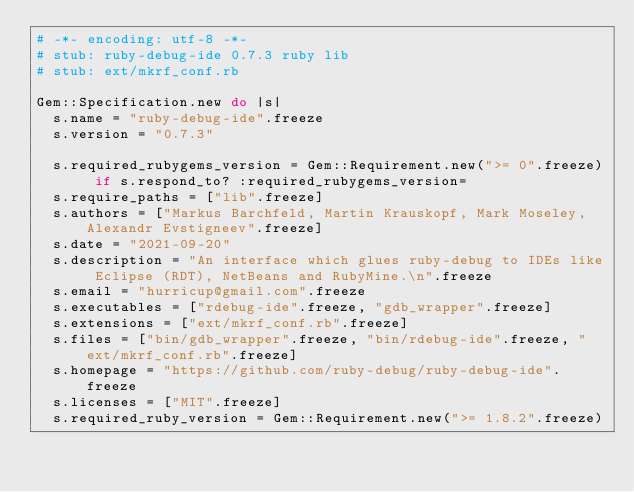<code> <loc_0><loc_0><loc_500><loc_500><_Ruby_># -*- encoding: utf-8 -*-
# stub: ruby-debug-ide 0.7.3 ruby lib
# stub: ext/mkrf_conf.rb

Gem::Specification.new do |s|
  s.name = "ruby-debug-ide".freeze
  s.version = "0.7.3"

  s.required_rubygems_version = Gem::Requirement.new(">= 0".freeze) if s.respond_to? :required_rubygems_version=
  s.require_paths = ["lib".freeze]
  s.authors = ["Markus Barchfeld, Martin Krauskopf, Mark Moseley, Alexandr Evstigneev".freeze]
  s.date = "2021-09-20"
  s.description = "An interface which glues ruby-debug to IDEs like Eclipse (RDT), NetBeans and RubyMine.\n".freeze
  s.email = "hurricup@gmail.com".freeze
  s.executables = ["rdebug-ide".freeze, "gdb_wrapper".freeze]
  s.extensions = ["ext/mkrf_conf.rb".freeze]
  s.files = ["bin/gdb_wrapper".freeze, "bin/rdebug-ide".freeze, "ext/mkrf_conf.rb".freeze]
  s.homepage = "https://github.com/ruby-debug/ruby-debug-ide".freeze
  s.licenses = ["MIT".freeze]
  s.required_ruby_version = Gem::Requirement.new(">= 1.8.2".freeze)</code> 